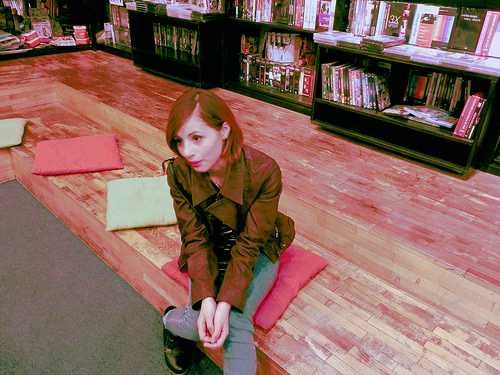<image>
Is the book on the floor? No. The book is not positioned on the floor. They may be near each other, but the book is not supported by or resting on top of the floor. 